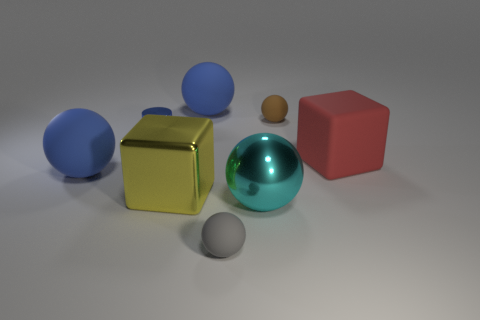Subtract all big shiny spheres. How many spheres are left? 4 Subtract all red cylinders. How many blue balls are left? 2 Subtract 2 balls. How many balls are left? 3 Subtract all spheres. How many objects are left? 3 Add 2 cylinders. How many objects exist? 10 Subtract all blue balls. How many balls are left? 3 Subtract all brown balls. Subtract all green cylinders. How many balls are left? 4 Add 8 red matte blocks. How many red matte blocks are left? 9 Add 1 large spheres. How many large spheres exist? 4 Subtract 0 green cubes. How many objects are left? 8 